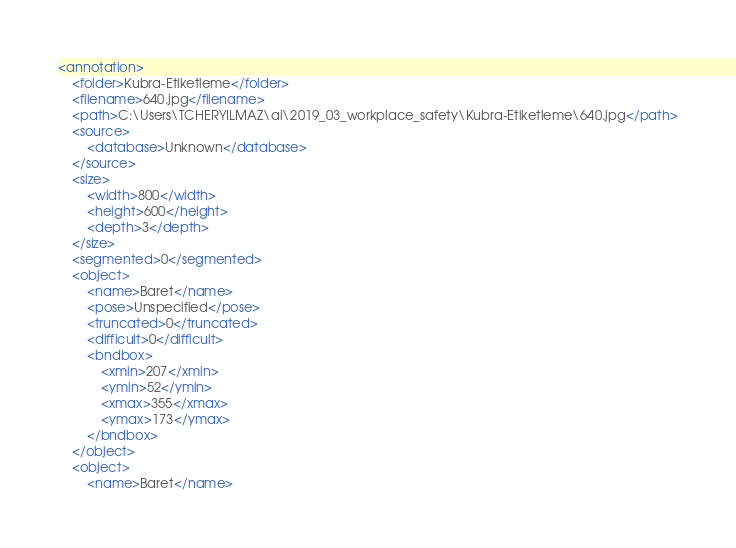Convert code to text. <code><loc_0><loc_0><loc_500><loc_500><_XML_><annotation>
	<folder>Kubra-Etiketleme</folder>
	<filename>640.jpg</filename>
	<path>C:\Users\TCHERYILMAZ\ai\2019_03_workplace_safety\Kubra-Etiketleme\640.jpg</path>
	<source>
		<database>Unknown</database>
	</source>
	<size>
		<width>800</width>
		<height>600</height>
		<depth>3</depth>
	</size>
	<segmented>0</segmented>
	<object>
		<name>Baret</name>
		<pose>Unspecified</pose>
		<truncated>0</truncated>
		<difficult>0</difficult>
		<bndbox>
			<xmin>207</xmin>
			<ymin>52</ymin>
			<xmax>355</xmax>
			<ymax>173</ymax>
		</bndbox>
	</object>
	<object>
		<name>Baret</name></code> 